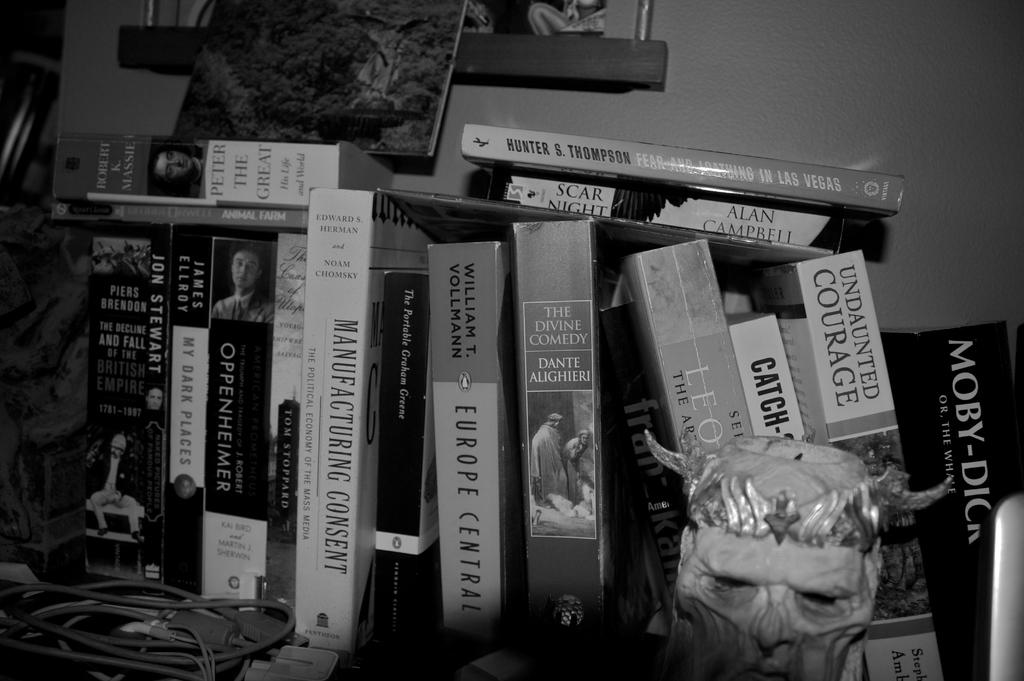What is the book all the way on the right?
Your response must be concise. Moby dick. Who wrote europe central?
Make the answer very short. William t. vollmann. 